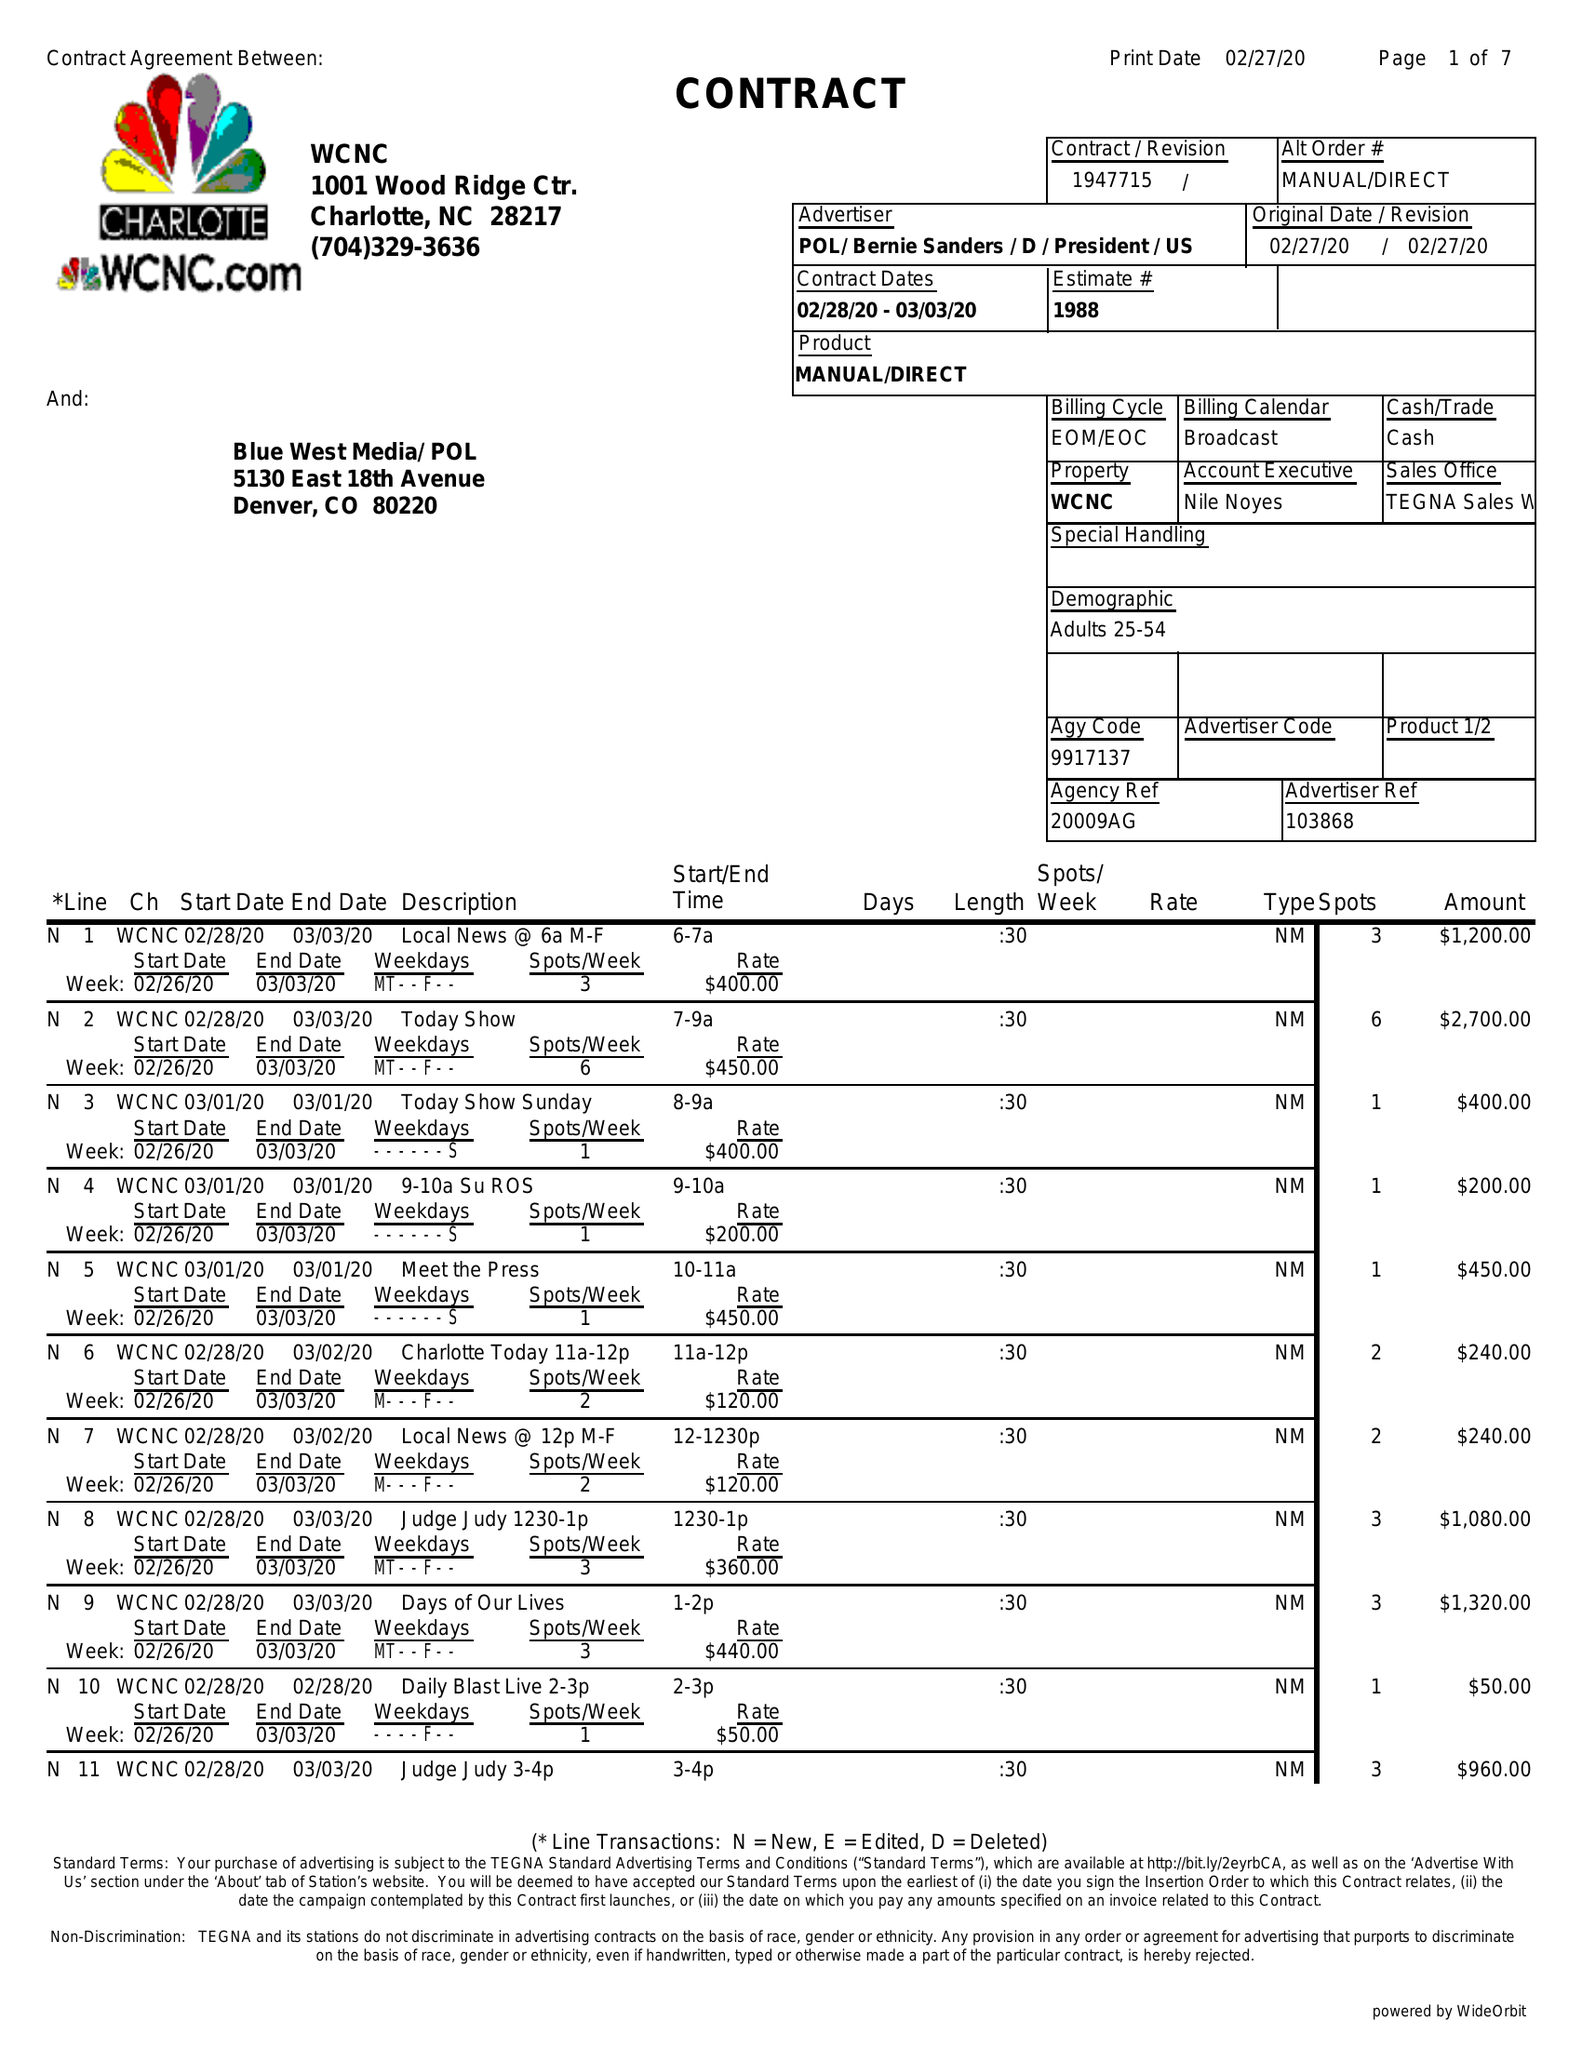What is the value for the contract_num?
Answer the question using a single word or phrase. 1947715 